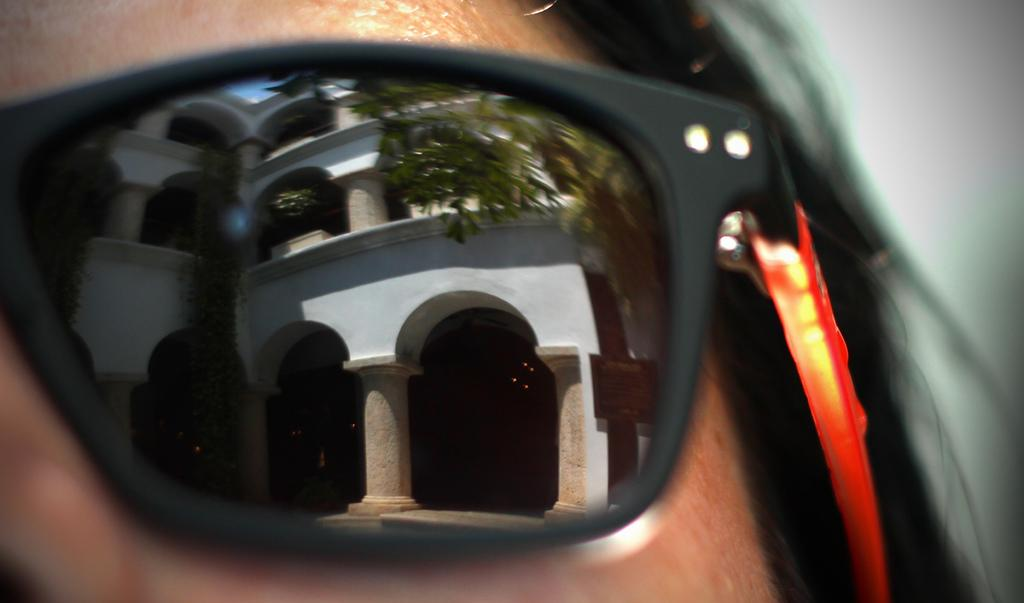What can be seen in the image? There is a person's face in the image, and the person is wearing goggles. What is the purpose of the goggles? The goggles are likely worn for protection or to enhance the person's vision. What is reflected on the goggles? There is a reflection of a building on the goggles. Can you describe the building? The building has walls, arches, and pillars. What else is visible in the image? There are leaves visible in the image. What type of mine can be seen in the image? There is no mine present in the image; it features a person's face wearing goggles with a reflection of a building. How many people are in the group in the image? There is no group of people present in the image; it only shows a person's face wearing goggles. 